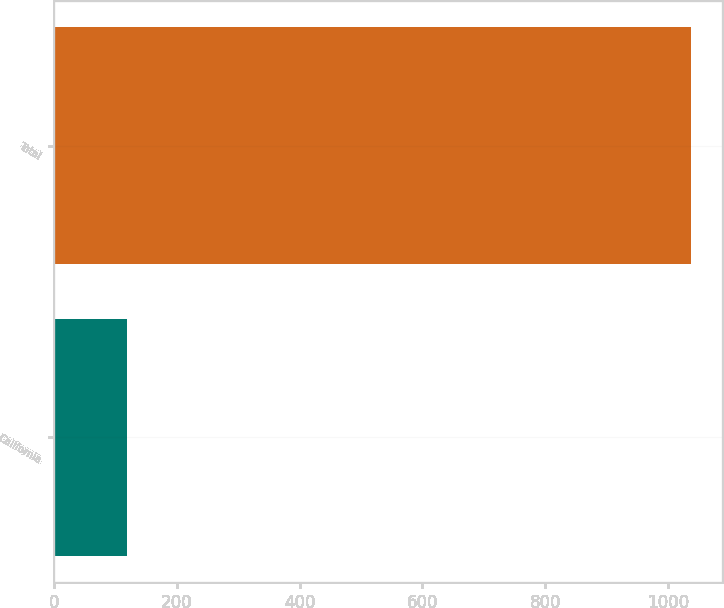<chart> <loc_0><loc_0><loc_500><loc_500><bar_chart><fcel>California<fcel>Total<nl><fcel>118<fcel>1037<nl></chart> 